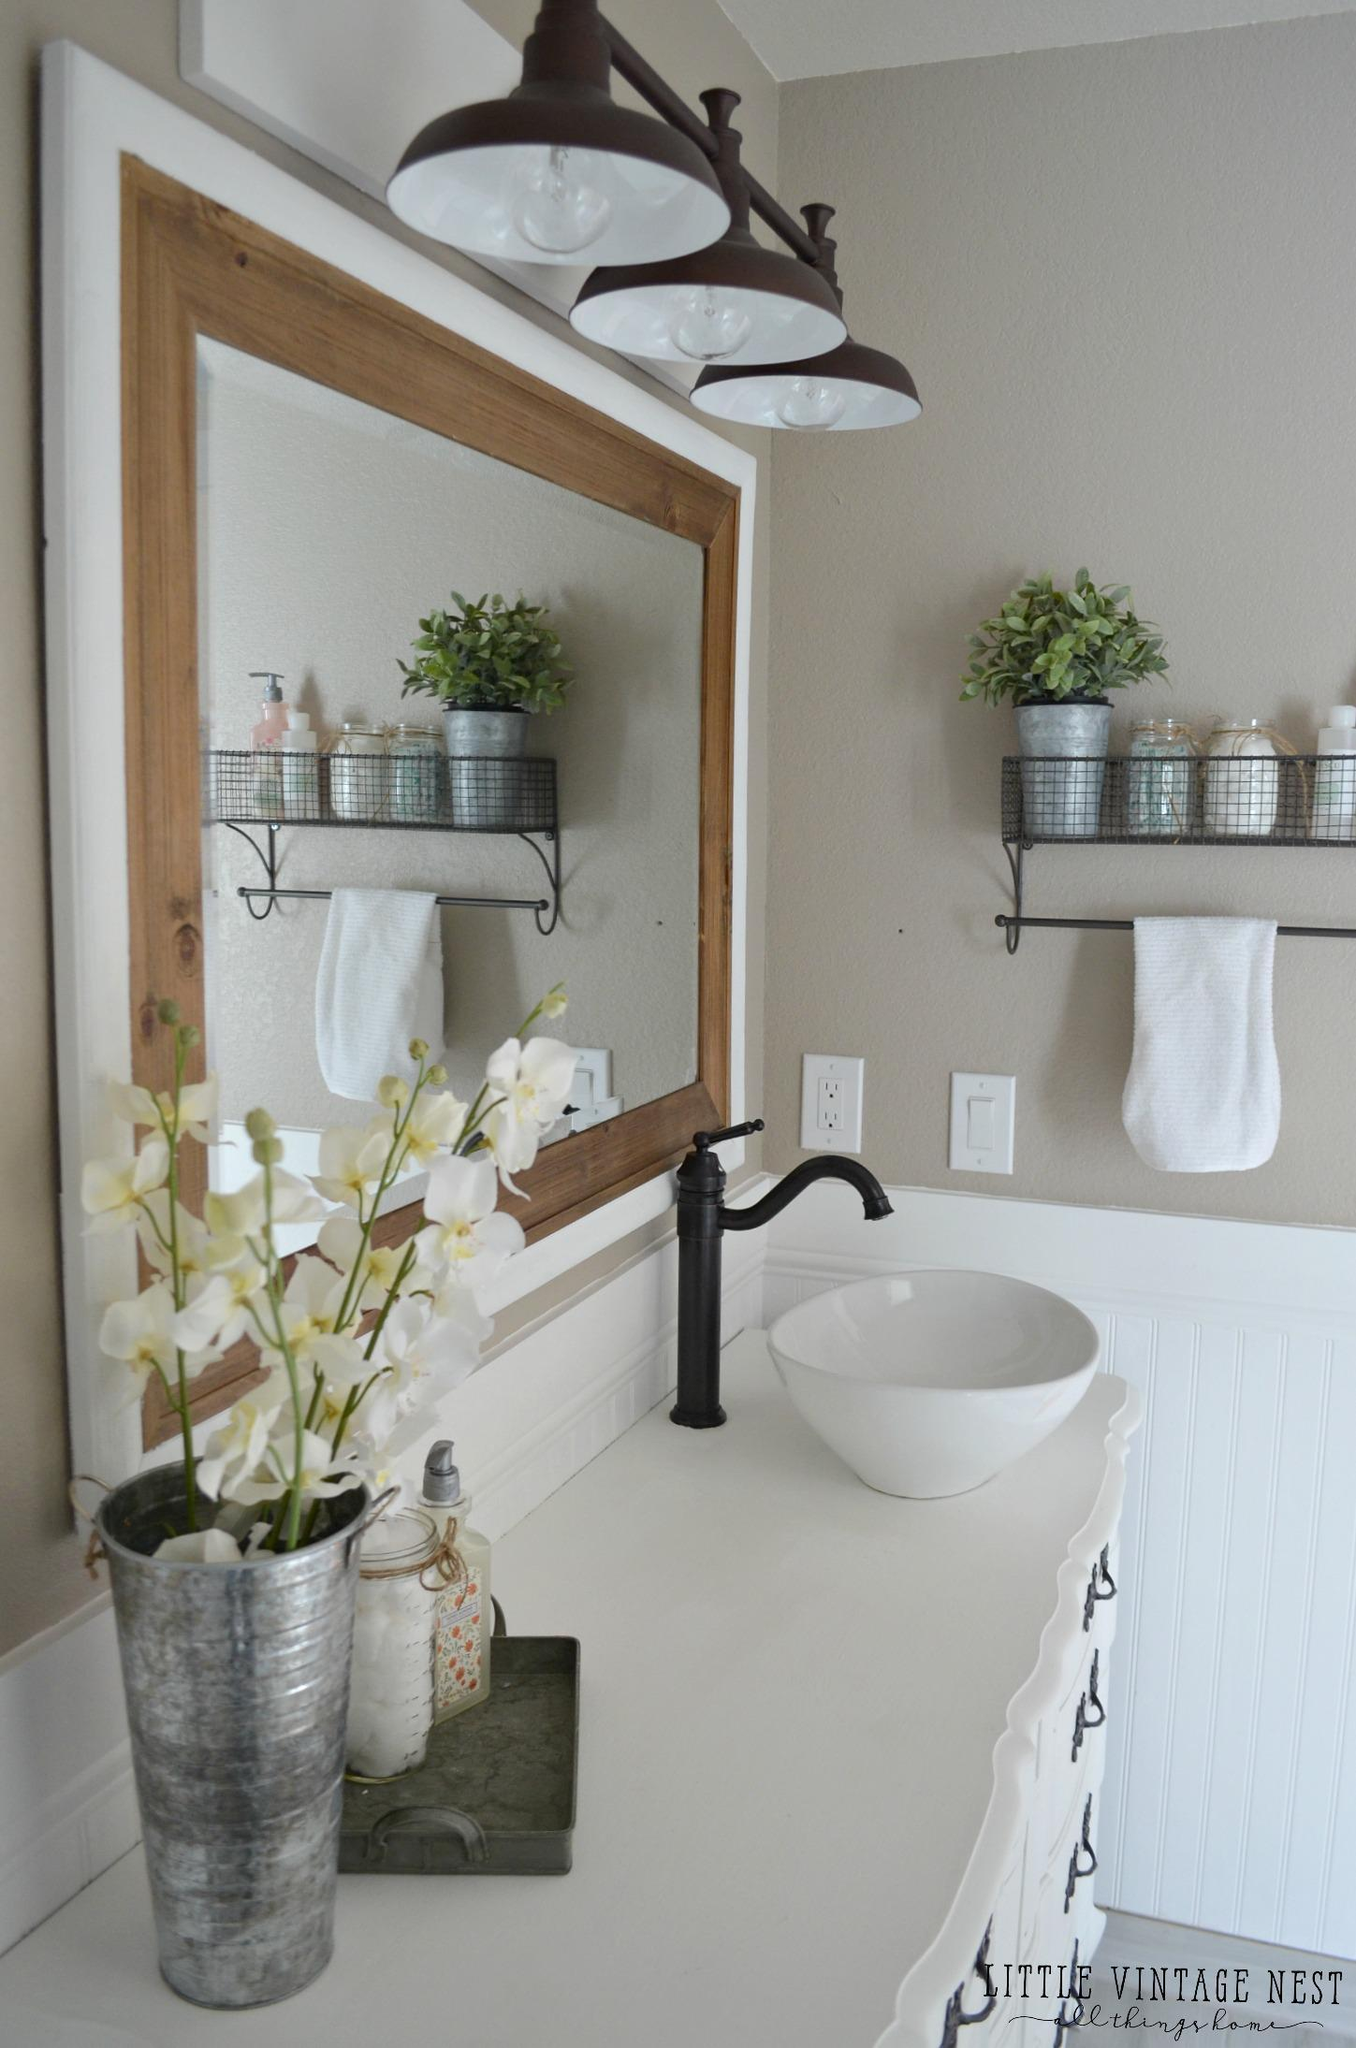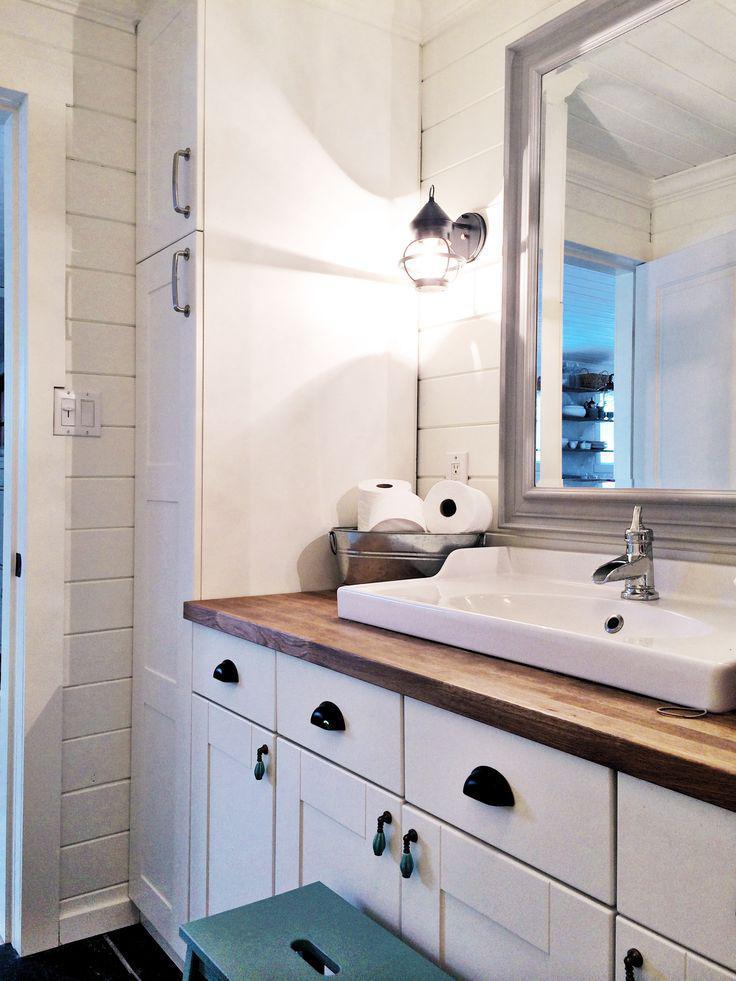The first image is the image on the left, the second image is the image on the right. Evaluate the accuracy of this statement regarding the images: "A row of three saucer shape lights are suspended above a mirror and sink.". Is it true? Answer yes or no. Yes. 